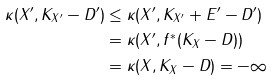<formula> <loc_0><loc_0><loc_500><loc_500>\kappa ( X ^ { \prime } , K _ { X ^ { \prime } } - D ^ { \prime } ) & \leq \kappa ( X ^ { \prime } , K _ { X ^ { \prime } } + E ^ { \prime } - D ^ { \prime } ) \\ & = \kappa ( X ^ { \prime } , f ^ { * } ( K _ { X } - D ) ) \\ & = \kappa ( X , K _ { X } - D ) = - \infty</formula> 